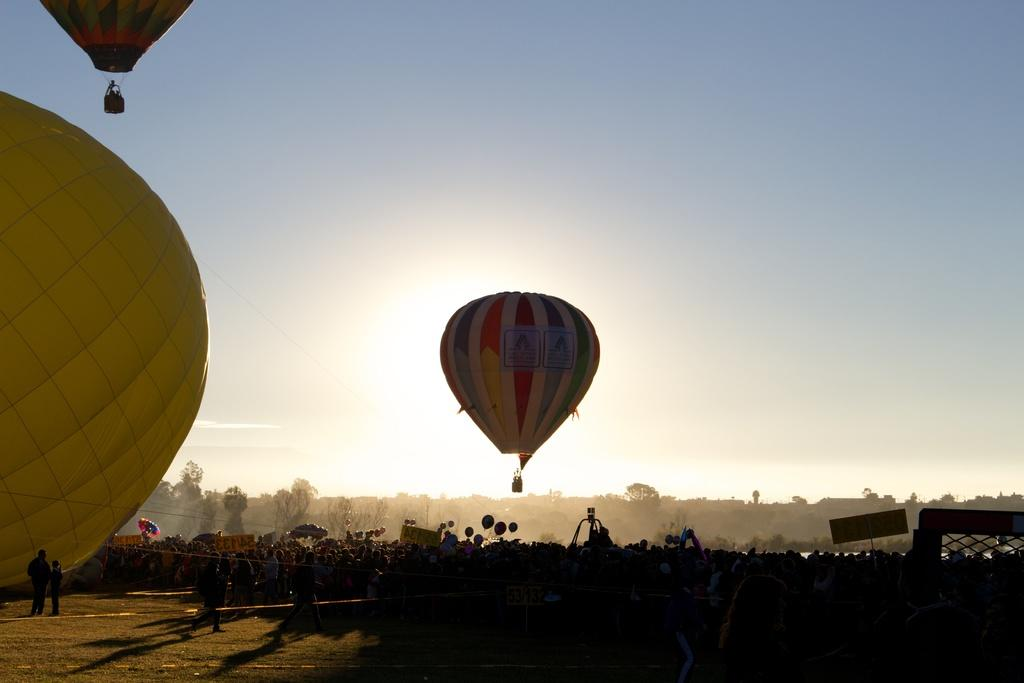What is floating in the air in the image? There are gas balloons in the air in the image. What can be seen on the surface below the gas balloons? There are people standing on the surface in the image. What type of vegetation is visible in the background of the image? There are trees in the background of the image. What type of furniture can be seen on the gas balloons in the image? There is no furniture present on the gas balloons in the image. Can you spot a frog hopping among the trees in the background? There is no frog visible in the image; only trees are present in the background. 